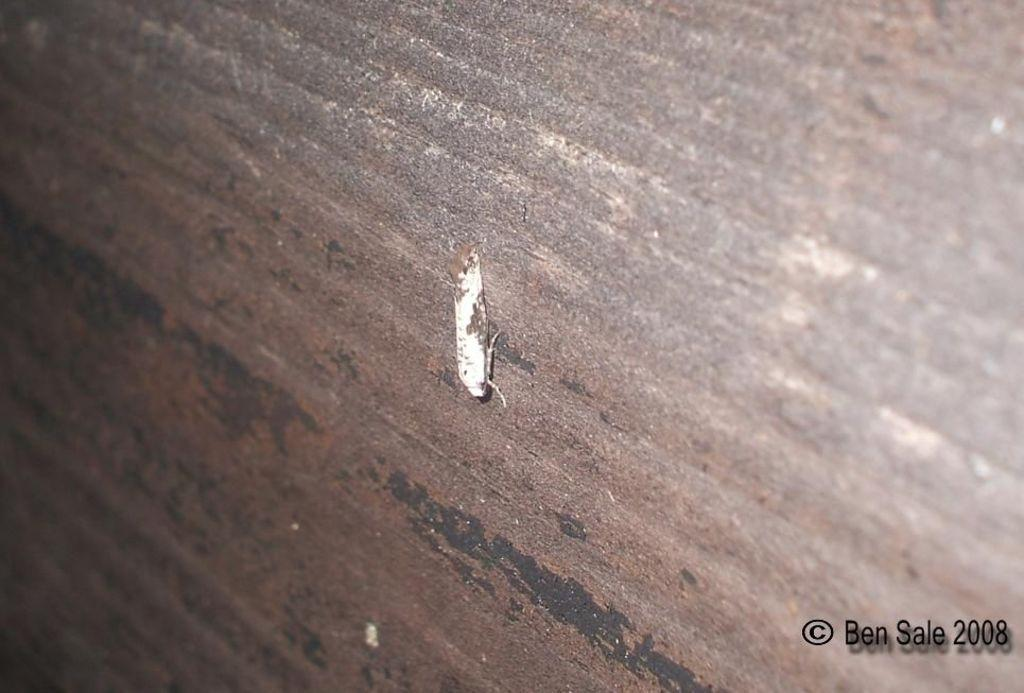What type of creature can be seen on the surface in the image? There is an insect on the surface in the image. Where is the text located in the image? The text is in the bottom right corner of the image. What type of act is the insect performing in the image? The insect is not performing any act in the image; it is simply present on the surface. 